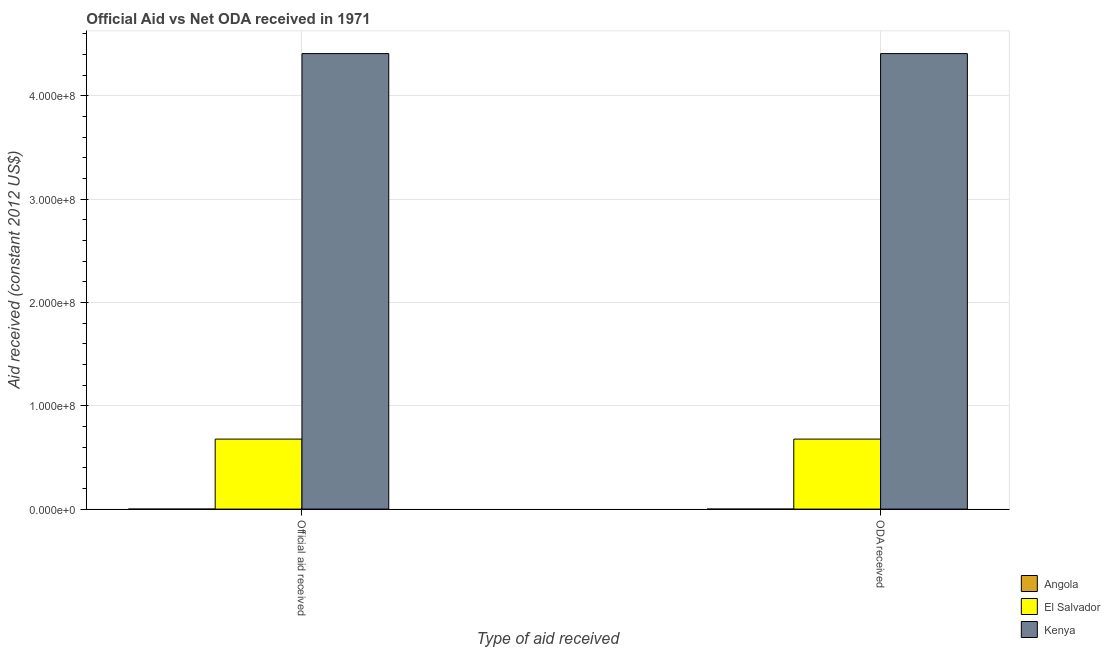How many bars are there on the 2nd tick from the left?
Provide a succinct answer. 2. How many bars are there on the 1st tick from the right?
Keep it short and to the point. 2. What is the label of the 1st group of bars from the left?
Offer a very short reply. Official aid received. What is the oda received in Kenya?
Offer a terse response. 4.41e+08. Across all countries, what is the maximum official aid received?
Your answer should be compact. 4.41e+08. Across all countries, what is the minimum oda received?
Keep it short and to the point. 0. In which country was the oda received maximum?
Your response must be concise. Kenya. What is the total official aid received in the graph?
Offer a terse response. 5.09e+08. What is the difference between the official aid received in Kenya and that in El Salvador?
Give a very brief answer. 3.73e+08. What is the difference between the official aid received in Angola and the oda received in Kenya?
Provide a succinct answer. -4.41e+08. What is the average oda received per country?
Give a very brief answer. 1.70e+08. In how many countries, is the official aid received greater than the average official aid received taken over all countries?
Provide a short and direct response. 1. Are all the bars in the graph horizontal?
Your answer should be very brief. No. How many countries are there in the graph?
Provide a succinct answer. 3. Are the values on the major ticks of Y-axis written in scientific E-notation?
Make the answer very short. Yes. Where does the legend appear in the graph?
Keep it short and to the point. Bottom right. How many legend labels are there?
Provide a short and direct response. 3. How are the legend labels stacked?
Provide a short and direct response. Vertical. What is the title of the graph?
Offer a very short reply. Official Aid vs Net ODA received in 1971 . Does "Somalia" appear as one of the legend labels in the graph?
Keep it short and to the point. No. What is the label or title of the X-axis?
Keep it short and to the point. Type of aid received. What is the label or title of the Y-axis?
Provide a short and direct response. Aid received (constant 2012 US$). What is the Aid received (constant 2012 US$) of Angola in Official aid received?
Your response must be concise. 0. What is the Aid received (constant 2012 US$) of El Salvador in Official aid received?
Offer a terse response. 6.78e+07. What is the Aid received (constant 2012 US$) in Kenya in Official aid received?
Offer a terse response. 4.41e+08. What is the Aid received (constant 2012 US$) in Angola in ODA received?
Your answer should be compact. 0. What is the Aid received (constant 2012 US$) in El Salvador in ODA received?
Your answer should be very brief. 6.78e+07. What is the Aid received (constant 2012 US$) of Kenya in ODA received?
Give a very brief answer. 4.41e+08. Across all Type of aid received, what is the maximum Aid received (constant 2012 US$) of El Salvador?
Make the answer very short. 6.78e+07. Across all Type of aid received, what is the maximum Aid received (constant 2012 US$) of Kenya?
Keep it short and to the point. 4.41e+08. Across all Type of aid received, what is the minimum Aid received (constant 2012 US$) of El Salvador?
Make the answer very short. 6.78e+07. Across all Type of aid received, what is the minimum Aid received (constant 2012 US$) of Kenya?
Provide a succinct answer. 4.41e+08. What is the total Aid received (constant 2012 US$) in Angola in the graph?
Your answer should be compact. 0. What is the total Aid received (constant 2012 US$) in El Salvador in the graph?
Ensure brevity in your answer.  1.36e+08. What is the total Aid received (constant 2012 US$) in Kenya in the graph?
Your answer should be compact. 8.82e+08. What is the difference between the Aid received (constant 2012 US$) in El Salvador in Official aid received and the Aid received (constant 2012 US$) in Kenya in ODA received?
Give a very brief answer. -3.73e+08. What is the average Aid received (constant 2012 US$) of Angola per Type of aid received?
Your answer should be compact. 0. What is the average Aid received (constant 2012 US$) in El Salvador per Type of aid received?
Offer a very short reply. 6.78e+07. What is the average Aid received (constant 2012 US$) in Kenya per Type of aid received?
Keep it short and to the point. 4.41e+08. What is the difference between the Aid received (constant 2012 US$) of El Salvador and Aid received (constant 2012 US$) of Kenya in Official aid received?
Ensure brevity in your answer.  -3.73e+08. What is the difference between the Aid received (constant 2012 US$) of El Salvador and Aid received (constant 2012 US$) of Kenya in ODA received?
Your response must be concise. -3.73e+08. What is the ratio of the Aid received (constant 2012 US$) in El Salvador in Official aid received to that in ODA received?
Your response must be concise. 1. What is the ratio of the Aid received (constant 2012 US$) in Kenya in Official aid received to that in ODA received?
Keep it short and to the point. 1. What is the difference between the highest and the second highest Aid received (constant 2012 US$) of El Salvador?
Your answer should be very brief. 0. What is the difference between the highest and the lowest Aid received (constant 2012 US$) of El Salvador?
Offer a terse response. 0. What is the difference between the highest and the lowest Aid received (constant 2012 US$) of Kenya?
Ensure brevity in your answer.  0. 